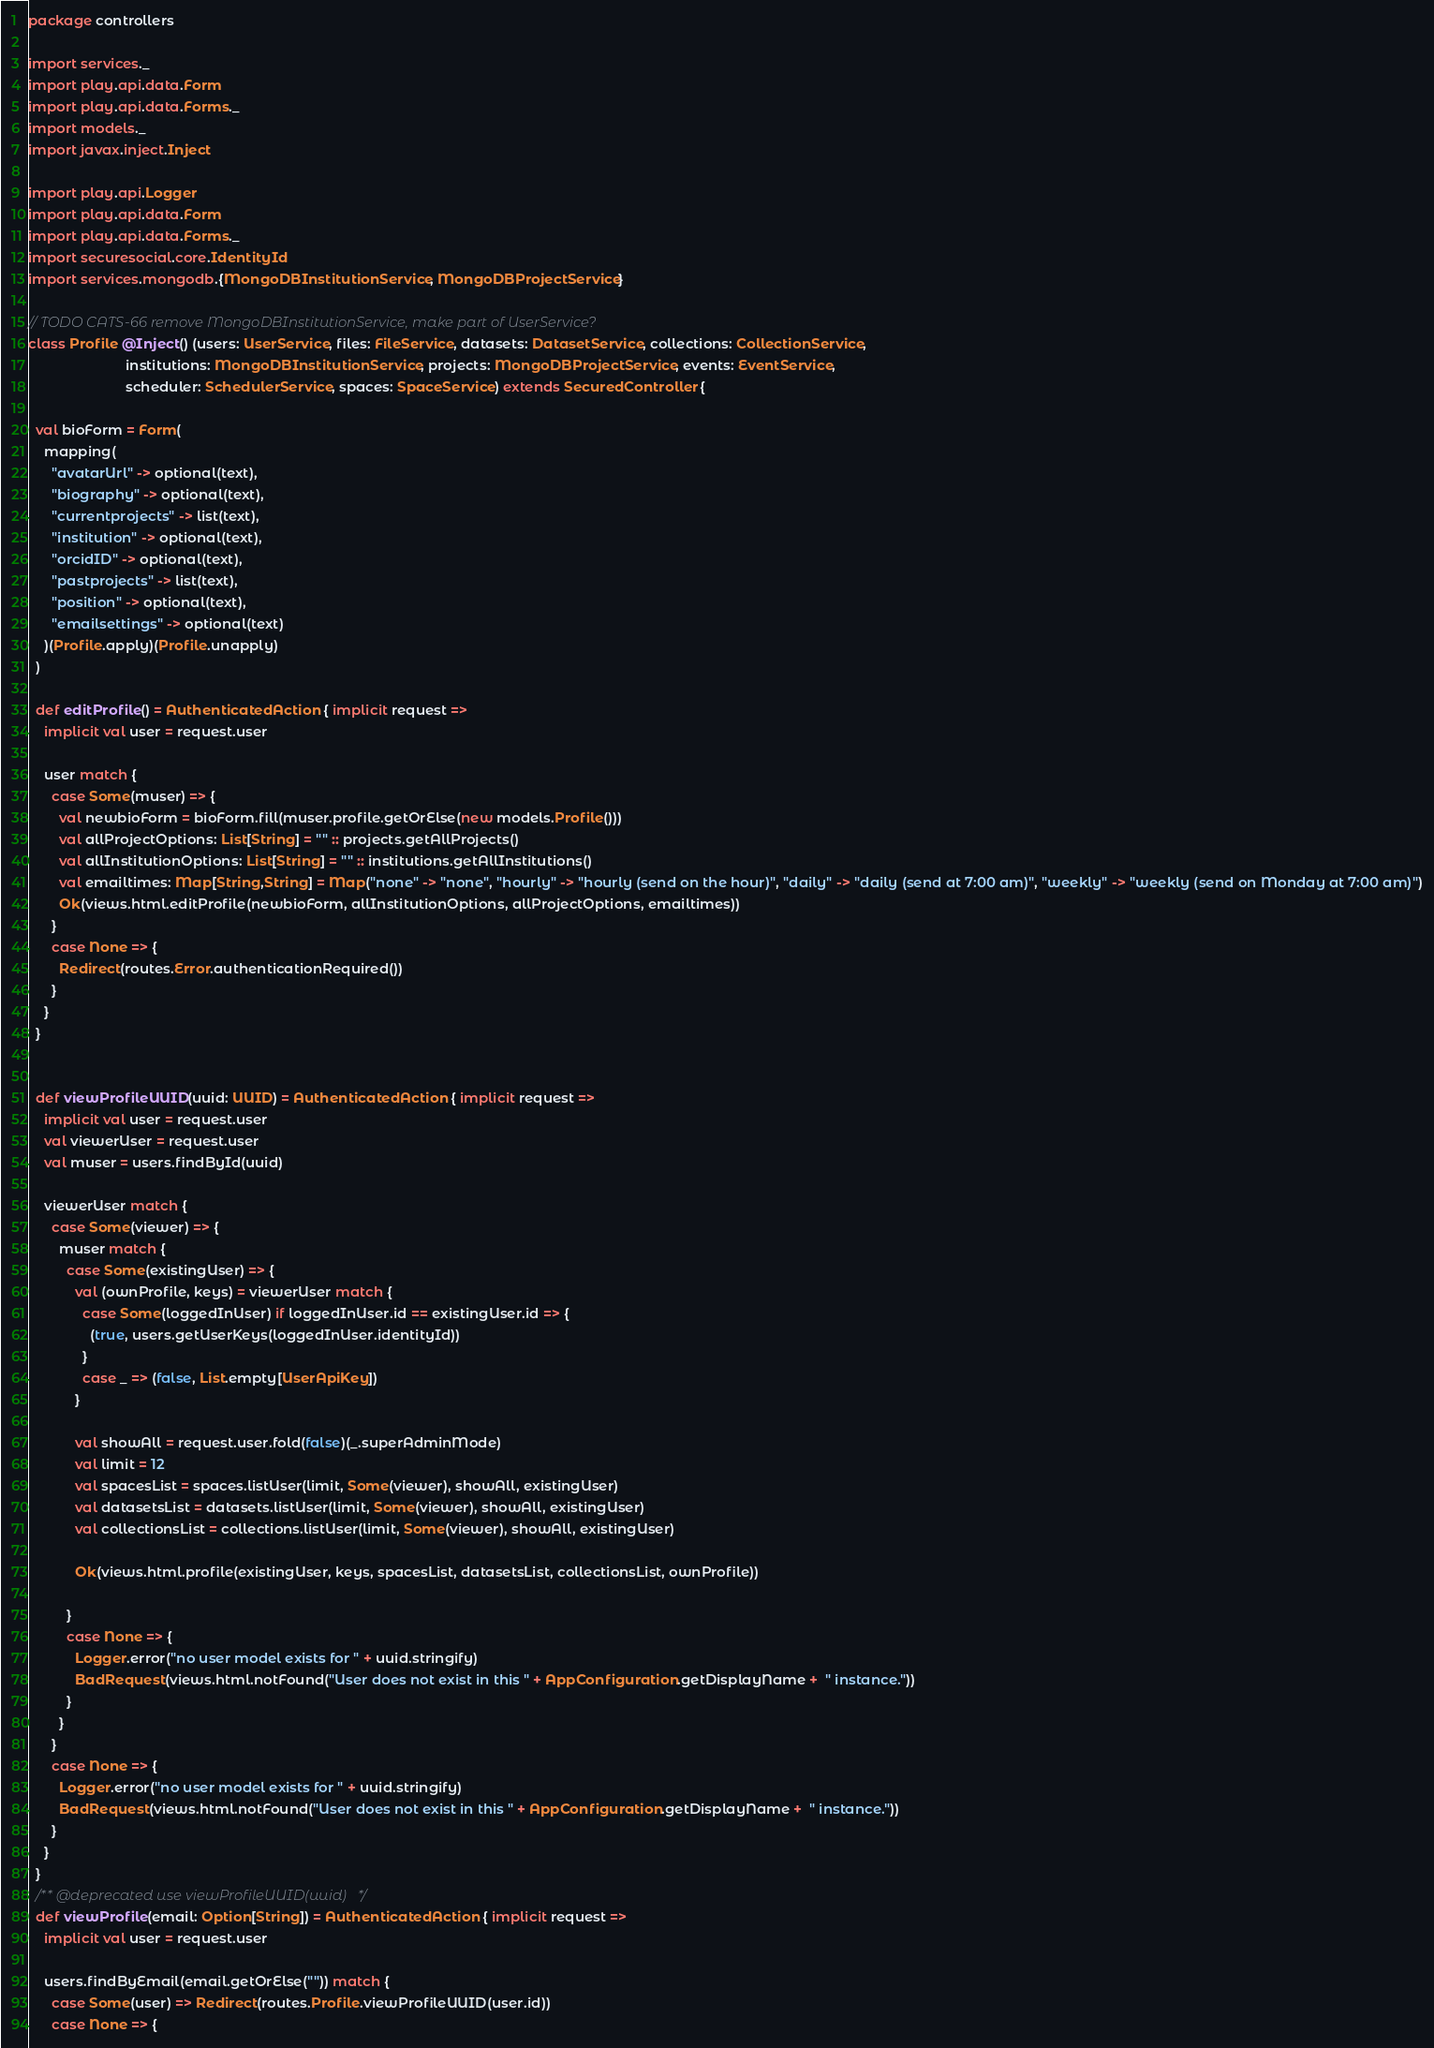Convert code to text. <code><loc_0><loc_0><loc_500><loc_500><_Scala_>package controllers

import services._
import play.api.data.Form
import play.api.data.Forms._
import models._
import javax.inject.Inject

import play.api.Logger
import play.api.data.Form
import play.api.data.Forms._
import securesocial.core.IdentityId
import services.mongodb.{MongoDBInstitutionService, MongoDBProjectService}

// TODO CATS-66 remove MongoDBInstitutionService, make part of UserService?
class Profile @Inject() (users: UserService, files: FileService, datasets: DatasetService, collections: CollectionService,
                         institutions: MongoDBInstitutionService, projects: MongoDBProjectService, events: EventService,
                         scheduler: SchedulerService, spaces: SpaceService) extends SecuredController {

  val bioForm = Form(
    mapping(
      "avatarUrl" -> optional(text),
      "biography" -> optional(text),
      "currentprojects" -> list(text),
      "institution" -> optional(text),
      "orcidID" -> optional(text),
      "pastprojects" -> list(text),
      "position" -> optional(text),
      "emailsettings" -> optional(text)
    )(Profile.apply)(Profile.unapply)
  )

  def editProfile() = AuthenticatedAction { implicit request =>
    implicit val user = request.user

    user match {
      case Some(muser) => {
        val newbioForm = bioForm.fill(muser.profile.getOrElse(new models.Profile()))
        val allProjectOptions: List[String] = "" :: projects.getAllProjects()
        val allInstitutionOptions: List[String] = "" :: institutions.getAllInstitutions()
        val emailtimes: Map[String,String] = Map("none" -> "none", "hourly" -> "hourly (send on the hour)", "daily" -> "daily (send at 7:00 am)", "weekly" -> "weekly (send on Monday at 7:00 am)")
        Ok(views.html.editProfile(newbioForm, allInstitutionOptions, allProjectOptions, emailtimes))
      }
      case None => {
        Redirect(routes.Error.authenticationRequired())
      }
    }
  }


  def viewProfileUUID(uuid: UUID) = AuthenticatedAction { implicit request =>
    implicit val user = request.user
    val viewerUser = request.user
    val muser = users.findById(uuid)

    viewerUser match {
      case Some(viewer) => {
        muser match {
          case Some(existingUser) => {
            val (ownProfile, keys) = viewerUser match {
              case Some(loggedInUser) if loggedInUser.id == existingUser.id => {
                (true, users.getUserKeys(loggedInUser.identityId))
              }
              case _ => (false, List.empty[UserApiKey])
            }

            val showAll = request.user.fold(false)(_.superAdminMode)
            val limit = 12
            val spacesList = spaces.listUser(limit, Some(viewer), showAll, existingUser)
            val datasetsList = datasets.listUser(limit, Some(viewer), showAll, existingUser)
            val collectionsList = collections.listUser(limit, Some(viewer), showAll, existingUser)

            Ok(views.html.profile(existingUser, keys, spacesList, datasetsList, collectionsList, ownProfile))

          }
          case None => {
            Logger.error("no user model exists for " + uuid.stringify)
            BadRequest(views.html.notFound("User does not exist in this " + AppConfiguration.getDisplayName +  " instance."))
          }
        }
      }
      case None => {
        Logger.error("no user model exists for " + uuid.stringify)
        BadRequest(views.html.notFound("User does not exist in this " + AppConfiguration.getDisplayName +  " instance."))
      }
    }
  }
  /** @deprecated use viewProfileUUID(uuid) */
  def viewProfile(email: Option[String]) = AuthenticatedAction { implicit request =>
    implicit val user = request.user

    users.findByEmail(email.getOrElse("")) match {
      case Some(user) => Redirect(routes.Profile.viewProfileUUID(user.id))
      case None => {</code> 